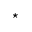Convert formula to latex. <formula><loc_0><loc_0><loc_500><loc_500>^ { * }</formula> 